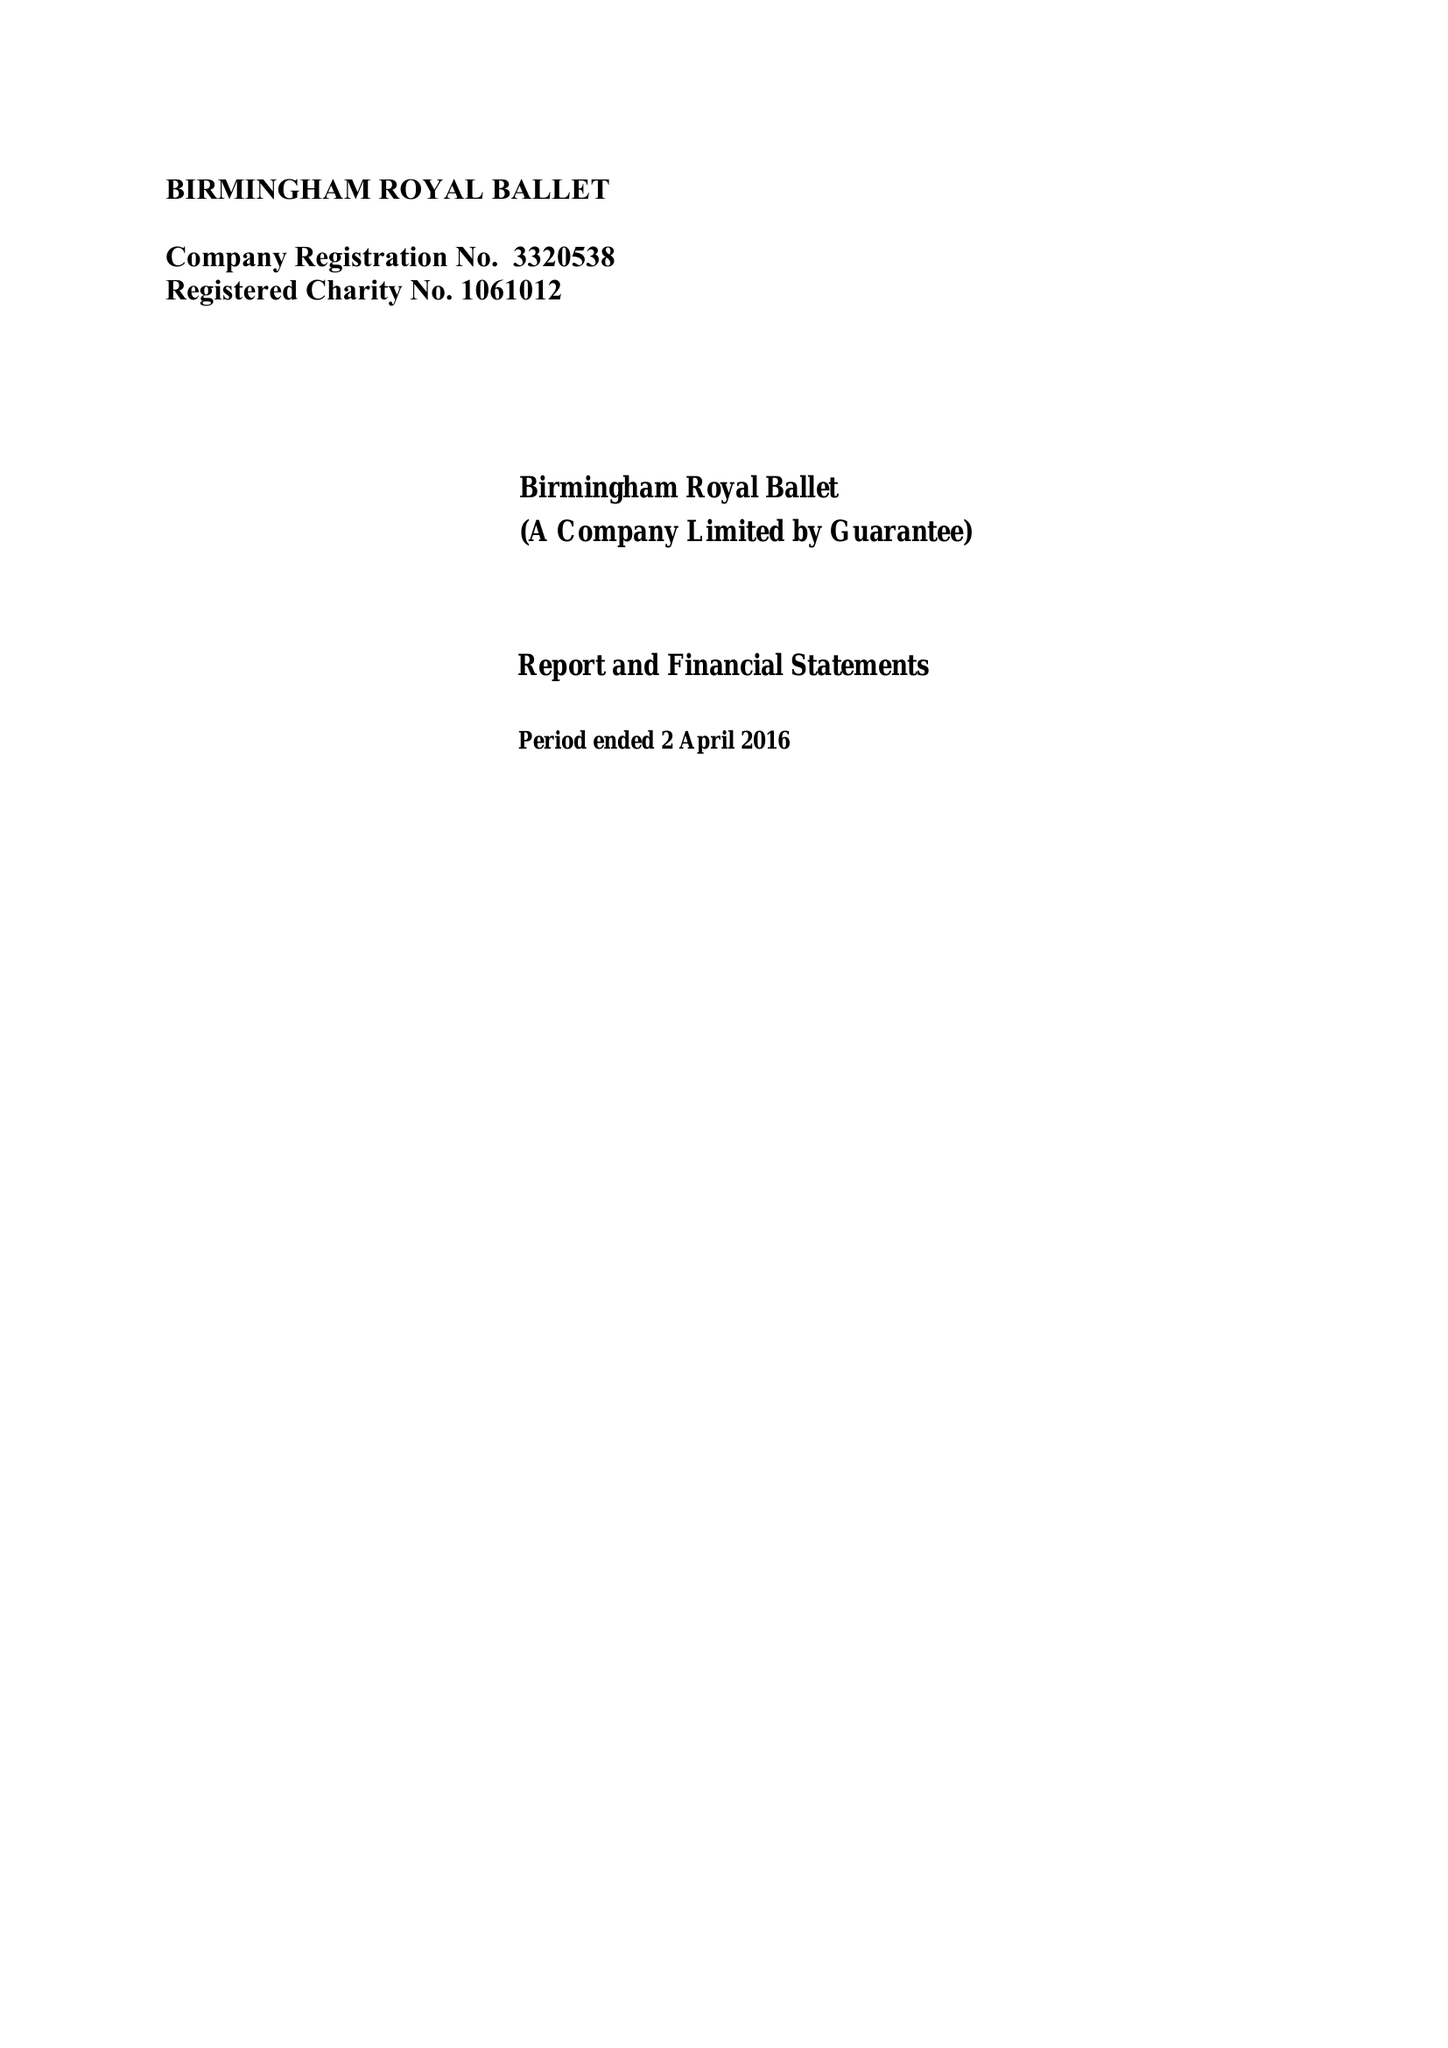What is the value for the address__street_line?
Answer the question using a single word or phrase. THORP STREET 